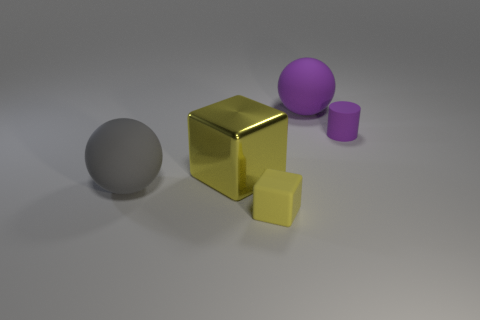Add 4 large red metal spheres. How many objects exist? 9 Subtract all spheres. How many objects are left? 3 Subtract 0 yellow cylinders. How many objects are left? 5 Subtract all yellow cylinders. Subtract all gray cubes. How many cylinders are left? 1 Subtract all yellow rubber things. Subtract all small purple objects. How many objects are left? 3 Add 5 big spheres. How many big spheres are left? 7 Add 1 small matte objects. How many small matte objects exist? 3 